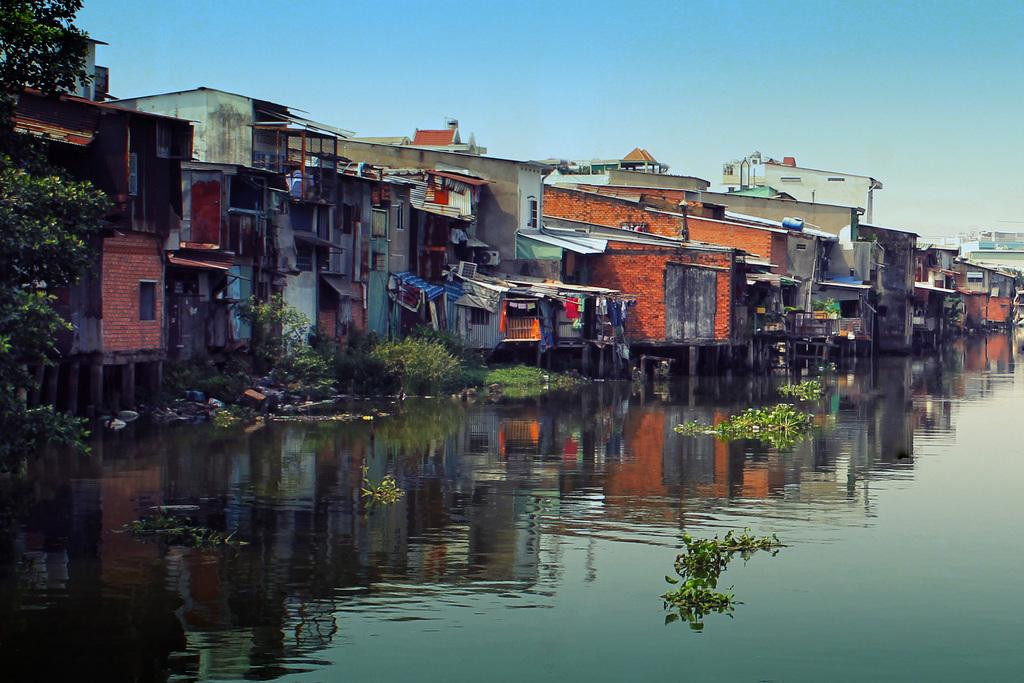What type of vegetation can be seen in the image? There are trees in the image. What type of structures are present in the image? There are buildings in the image. What natural element is visible in the image? There is water visible in the image. What is growing in the water? There are plants in the water. What can be seen in the sky behind the buildings? The sky is visible behind the buildings. Where are the children playing in the image? There are no children present in the image. What type of produce is growing on the scarecrow in the image? There is no scarecrow present in the image. 